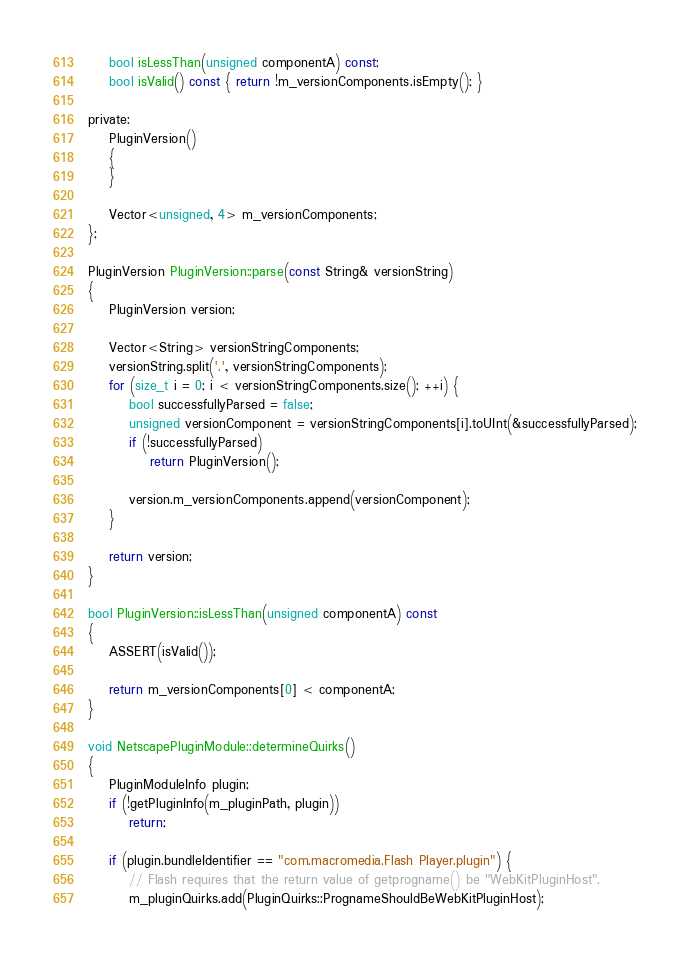<code> <loc_0><loc_0><loc_500><loc_500><_ObjectiveC_>
    bool isLessThan(unsigned componentA) const;
    bool isValid() const { return !m_versionComponents.isEmpty(); }

private:
    PluginVersion()
    {
    }

    Vector<unsigned, 4> m_versionComponents;
};

PluginVersion PluginVersion::parse(const String& versionString)
{
    PluginVersion version;

    Vector<String> versionStringComponents;
    versionString.split('.', versionStringComponents);
    for (size_t i = 0; i < versionStringComponents.size(); ++i) {
        bool successfullyParsed = false;
        unsigned versionComponent = versionStringComponents[i].toUInt(&successfullyParsed);
        if (!successfullyParsed)
            return PluginVersion();

        version.m_versionComponents.append(versionComponent);
    }

    return version;
}

bool PluginVersion::isLessThan(unsigned componentA) const
{
    ASSERT(isValid());

    return m_versionComponents[0] < componentA;
}

void NetscapePluginModule::determineQuirks()
{
    PluginModuleInfo plugin;
    if (!getPluginInfo(m_pluginPath, plugin))
        return;

    if (plugin.bundleIdentifier == "com.macromedia.Flash Player.plugin") {
        // Flash requires that the return value of getprogname() be "WebKitPluginHost".
        m_pluginQuirks.add(PluginQuirks::PrognameShouldBeWebKitPluginHost);
</code> 